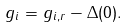<formula> <loc_0><loc_0><loc_500><loc_500>g _ { i } = g _ { i , r } - \Delta ( 0 ) .</formula> 